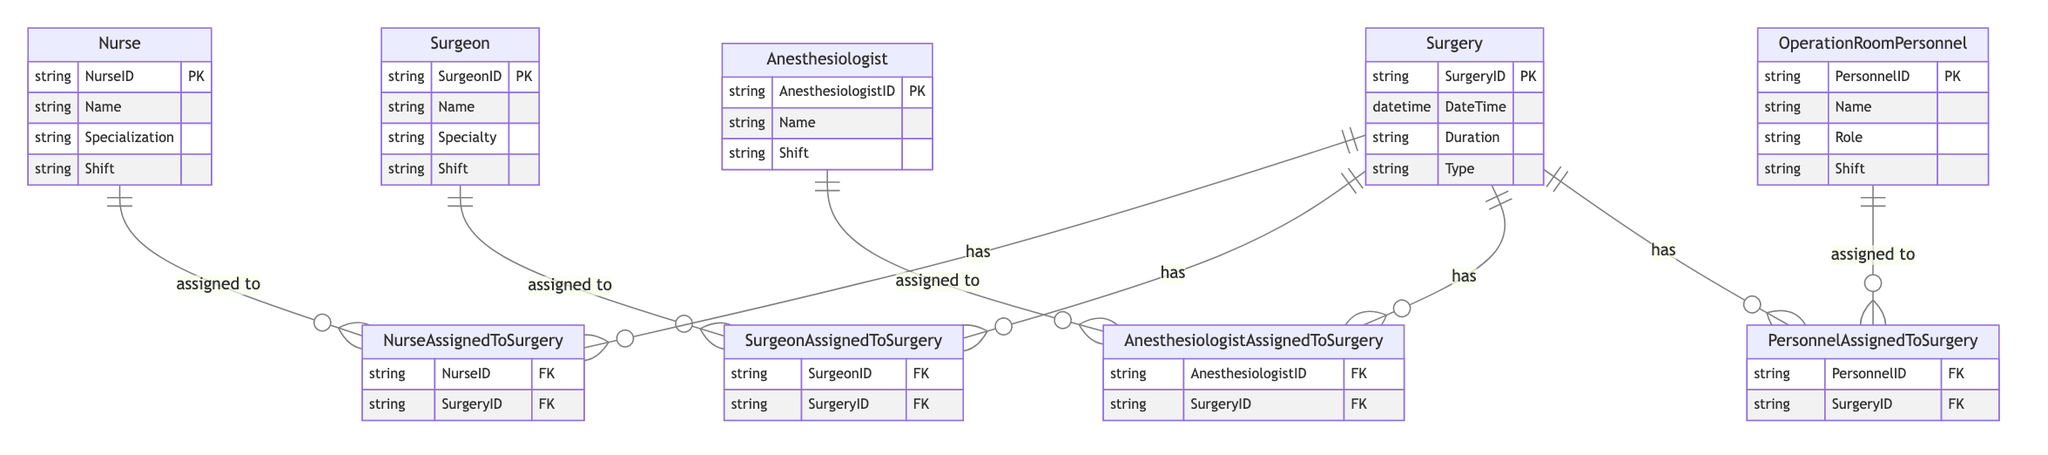What entities are involved in the shift schedule? The diagram lists five main entities: Nurse, Surgeon, Anesthesiologist, Operation Room Personnel, and Surgery, all of which are involved in the coordination of the operating room and shift schedules.
Answer: Nurse, Surgeon, Anesthesiologist, Operation Room Personnel, Surgery How many relationships exist between personnel and surgery? There are four relationships defined in the diagram: NurseAssignedToSurgery, SurgeonAssignedToSurgery, AnesthesiologistAssignedToSurgery, and PersonnelAssignedToSurgery, indicating that each type of personnel can be assigned to a surgery.
Answer: Four What is the primary key for the Nurse entity? The diagram shows that the primary key for the Nurse entity is NurseID, which uniquely identifies each nurse in the system.
Answer: NurseID How does an Anesthesiologist relate to a Surgery? The diagram indicates that there is a relationship called AnesthesiologistAssignedToSurgery, which links an Anesthesiologist to a Surgery using their respective IDs.
Answer: Assigned to What attributes do all personnel entities share? Each personnel entity, whether Nurse, Surgeon, Anesthesiologist, or Operation Room Personnel, has a Shift attribute, indicating when they are scheduled to work.
Answer: Shift How many entities have a primary key? The diagram indicates that there are five entities, each with a defined primary key, ensuring that every entry in these entities can be uniquely identified.
Answer: Five What is the relationship pattern between Surgery and the personnel entities? The diagram illustrates that each type of personnel is assigned to a Surgery through a specific relationship, demonstrating that every surgery has a combination of Nurses, Surgeons, Anesthesiologists, and other personnel.
Answer: Has Which entity has the attribute "Specialization"? The Nurse entity includes the attribute "Specialization," indicating that nurses can have different areas of focus or expertise within their profession.
Answer: Nurse What relationship connects Operation Room Personnel to Surgery? The diagram shows that Operations Room Personnel are connected to Surgery through the PersonnelAssignedToSurgery relationship, which implies that they can be part of a surgical team.
Answer: PersonnelAssignedToSurgery 